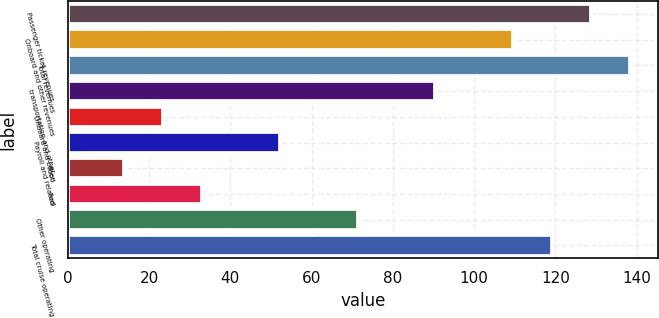Convert chart to OTSL. <chart><loc_0><loc_0><loc_500><loc_500><bar_chart><fcel>Passenger ticket revenues<fcel>Onboard and other revenues<fcel>Total revenues<fcel>transportation and other<fcel>Onboard and other<fcel>Payroll and related<fcel>Food<fcel>Fuel<fcel>Other operating<fcel>Total cruise operating<nl><fcel>128.71<fcel>109.57<fcel>138.28<fcel>90.43<fcel>23.44<fcel>52.15<fcel>13.87<fcel>33.01<fcel>71.29<fcel>119.14<nl></chart> 